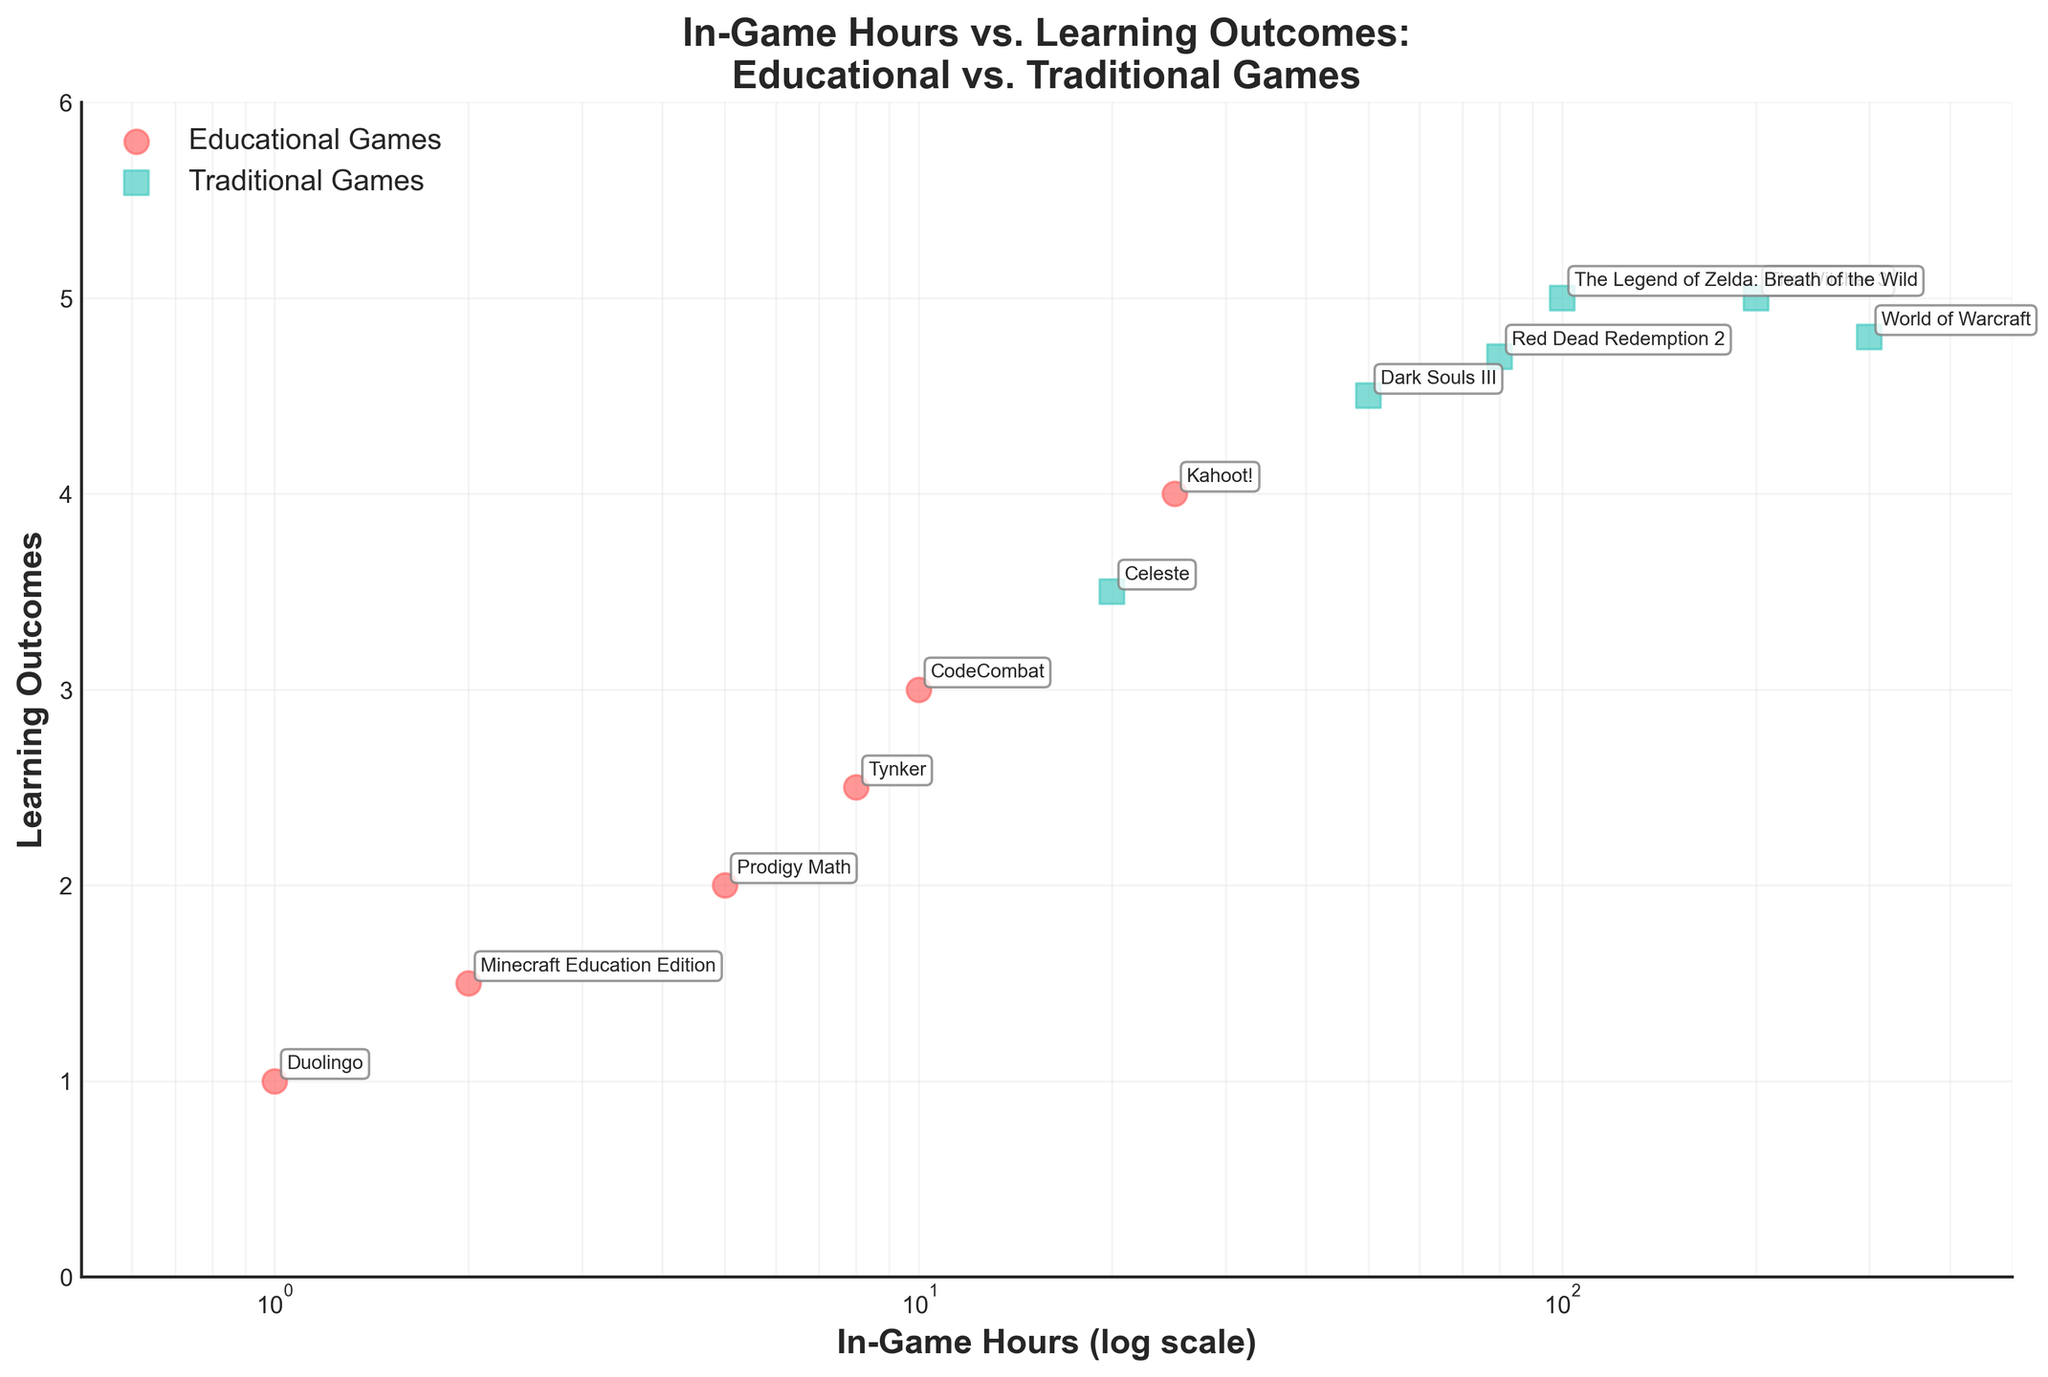How many types of games are represented in the plot? The plot shows two distinct types of games: educational and traditional, distinguished by different colors and markers.
Answer: 2 What is the highest learning outcome for educational games, and which game achieved it? The educational game with the highest learning outcome has a value of 4, which is achieved by Kahoot!
Answer: Kahoot! with 4 Which game required the most in-game hours, and how many hours were played? The game with the most in-game hours is World of Warcraft, with 300 hours played.
Answer: World of Warcraft, 300 hours How does The Witcher 3's learning outcome compare to the highest learning outcome in educational games? The Witcher 3's learning outcome is 5, which is higher than the highest learning outcome in educational games, which is 4 by Kahoot!.
Answer: Higher What are the titles of the games that have exactly the same learning outcome values? Both The Witcher 3 and The Legend of Zelda: Breath of the Wild have the same learning outcome value of 5.
Answer: The Witcher 3 and The Legend of Zelda: Breath of the Wild What is the combined total number of in-game hours played for Minecraft Education Edition and Celeste? Minecraft Education Edition has 2 hours and Celeste has 20 hours, so the total is 2 + 20 = 22 hours.
Answer: 22 hours Which game has a learning outcome of 4.5 and how many hours in-game were played for this game? Dark Souls III has a learning outcome of 4.5, and 50 in-game hours were played for this game.
Answer: Dark Souls III, 50 hours Compare the average learning outcomes between educational and traditional games. The learning outcomes for educational games are 1, 3, 2, 1.5, 2.5, and 4. For traditional games, they are 5, 4.5, 5, 4.8, 3.5, and 4.7. The average for educational is (1+3+2+1.5+2.5+4)/6 = 2.5. For traditional, (5+4.5+5+4.8+3.5+4.7)/6 = 4.58.
Answer: Educational: 2.5, Traditional: 4.58 Describe the general trend of learning outcomes in traditional games as in-game hours increase. The scatter plot shows that traditional games generally maintain high learning outcomes as in-game hours increase, without a significant drop even at high hours played.
Answer: Maintain high outcomes 